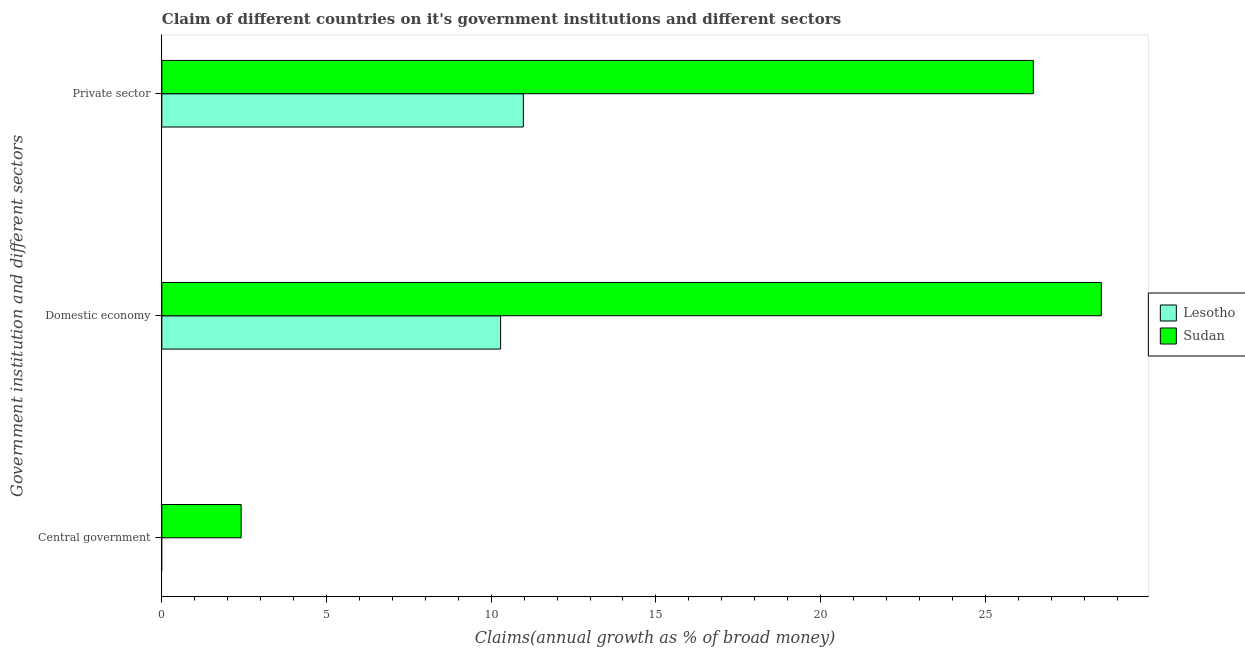Are the number of bars per tick equal to the number of legend labels?
Give a very brief answer. No. How many bars are there on the 2nd tick from the top?
Your answer should be very brief. 2. What is the label of the 1st group of bars from the top?
Offer a terse response. Private sector. What is the percentage of claim on the private sector in Sudan?
Give a very brief answer. 26.46. Across all countries, what is the maximum percentage of claim on the private sector?
Ensure brevity in your answer.  26.46. Across all countries, what is the minimum percentage of claim on the central government?
Ensure brevity in your answer.  0. In which country was the percentage of claim on the central government maximum?
Your answer should be very brief. Sudan. What is the total percentage of claim on the domestic economy in the graph?
Offer a terse response. 38.81. What is the difference between the percentage of claim on the domestic economy in Sudan and that in Lesotho?
Ensure brevity in your answer.  18.24. What is the difference between the percentage of claim on the domestic economy in Lesotho and the percentage of claim on the private sector in Sudan?
Your response must be concise. -16.17. What is the average percentage of claim on the central government per country?
Your response must be concise. 1.2. What is the difference between the percentage of claim on the domestic economy and percentage of claim on the private sector in Sudan?
Provide a short and direct response. 2.06. What is the ratio of the percentage of claim on the private sector in Sudan to that in Lesotho?
Your answer should be compact. 2.41. Is the difference between the percentage of claim on the private sector in Lesotho and Sudan greater than the difference between the percentage of claim on the domestic economy in Lesotho and Sudan?
Offer a very short reply. Yes. What is the difference between the highest and the second highest percentage of claim on the private sector?
Offer a very short reply. 15.48. What is the difference between the highest and the lowest percentage of claim on the domestic economy?
Provide a short and direct response. 18.24. How many bars are there?
Offer a very short reply. 5. How many countries are there in the graph?
Offer a very short reply. 2. How are the legend labels stacked?
Offer a terse response. Vertical. What is the title of the graph?
Keep it short and to the point. Claim of different countries on it's government institutions and different sectors. What is the label or title of the X-axis?
Offer a terse response. Claims(annual growth as % of broad money). What is the label or title of the Y-axis?
Your answer should be compact. Government institution and different sectors. What is the Claims(annual growth as % of broad money) of Lesotho in Central government?
Your answer should be very brief. 0. What is the Claims(annual growth as % of broad money) in Sudan in Central government?
Make the answer very short. 2.41. What is the Claims(annual growth as % of broad money) in Lesotho in Domestic economy?
Your answer should be compact. 10.29. What is the Claims(annual growth as % of broad money) in Sudan in Domestic economy?
Keep it short and to the point. 28.52. What is the Claims(annual growth as % of broad money) of Lesotho in Private sector?
Keep it short and to the point. 10.98. What is the Claims(annual growth as % of broad money) of Sudan in Private sector?
Make the answer very short. 26.46. Across all Government institution and different sectors, what is the maximum Claims(annual growth as % of broad money) of Lesotho?
Make the answer very short. 10.98. Across all Government institution and different sectors, what is the maximum Claims(annual growth as % of broad money) in Sudan?
Make the answer very short. 28.52. Across all Government institution and different sectors, what is the minimum Claims(annual growth as % of broad money) of Lesotho?
Your answer should be compact. 0. Across all Government institution and different sectors, what is the minimum Claims(annual growth as % of broad money) of Sudan?
Your answer should be very brief. 2.41. What is the total Claims(annual growth as % of broad money) in Lesotho in the graph?
Your response must be concise. 21.26. What is the total Claims(annual growth as % of broad money) of Sudan in the graph?
Your answer should be very brief. 57.39. What is the difference between the Claims(annual growth as % of broad money) in Sudan in Central government and that in Domestic economy?
Your answer should be compact. -26.12. What is the difference between the Claims(annual growth as % of broad money) in Sudan in Central government and that in Private sector?
Your answer should be very brief. -24.05. What is the difference between the Claims(annual growth as % of broad money) of Lesotho in Domestic economy and that in Private sector?
Your response must be concise. -0.69. What is the difference between the Claims(annual growth as % of broad money) in Sudan in Domestic economy and that in Private sector?
Offer a terse response. 2.06. What is the difference between the Claims(annual growth as % of broad money) in Lesotho in Domestic economy and the Claims(annual growth as % of broad money) in Sudan in Private sector?
Keep it short and to the point. -16.17. What is the average Claims(annual growth as % of broad money) in Lesotho per Government institution and different sectors?
Keep it short and to the point. 7.09. What is the average Claims(annual growth as % of broad money) in Sudan per Government institution and different sectors?
Offer a terse response. 19.13. What is the difference between the Claims(annual growth as % of broad money) in Lesotho and Claims(annual growth as % of broad money) in Sudan in Domestic economy?
Give a very brief answer. -18.24. What is the difference between the Claims(annual growth as % of broad money) in Lesotho and Claims(annual growth as % of broad money) in Sudan in Private sector?
Your response must be concise. -15.48. What is the ratio of the Claims(annual growth as % of broad money) of Sudan in Central government to that in Domestic economy?
Your answer should be very brief. 0.08. What is the ratio of the Claims(annual growth as % of broad money) in Sudan in Central government to that in Private sector?
Give a very brief answer. 0.09. What is the ratio of the Claims(annual growth as % of broad money) in Lesotho in Domestic economy to that in Private sector?
Provide a short and direct response. 0.94. What is the ratio of the Claims(annual growth as % of broad money) of Sudan in Domestic economy to that in Private sector?
Provide a succinct answer. 1.08. What is the difference between the highest and the second highest Claims(annual growth as % of broad money) of Sudan?
Make the answer very short. 2.06. What is the difference between the highest and the lowest Claims(annual growth as % of broad money) in Lesotho?
Provide a short and direct response. 10.98. What is the difference between the highest and the lowest Claims(annual growth as % of broad money) in Sudan?
Your answer should be compact. 26.12. 